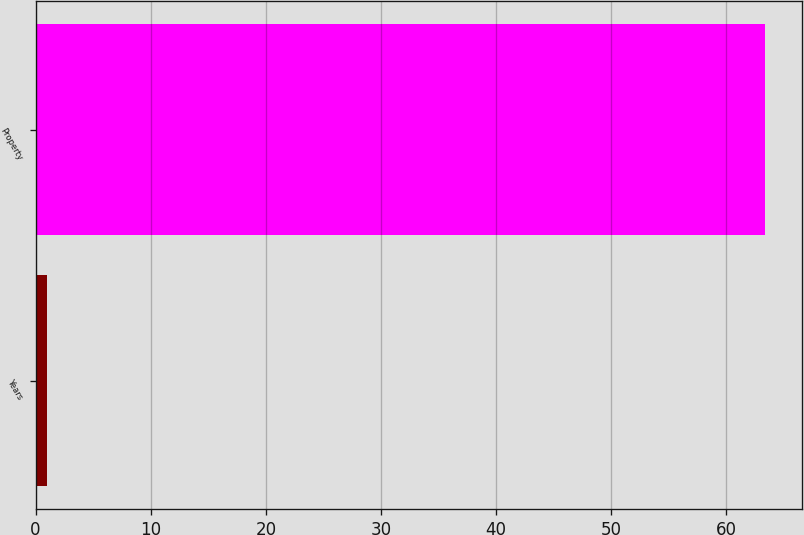Convert chart to OTSL. <chart><loc_0><loc_0><loc_500><loc_500><bar_chart><fcel>Years<fcel>Property<nl><fcel>1<fcel>63.4<nl></chart> 